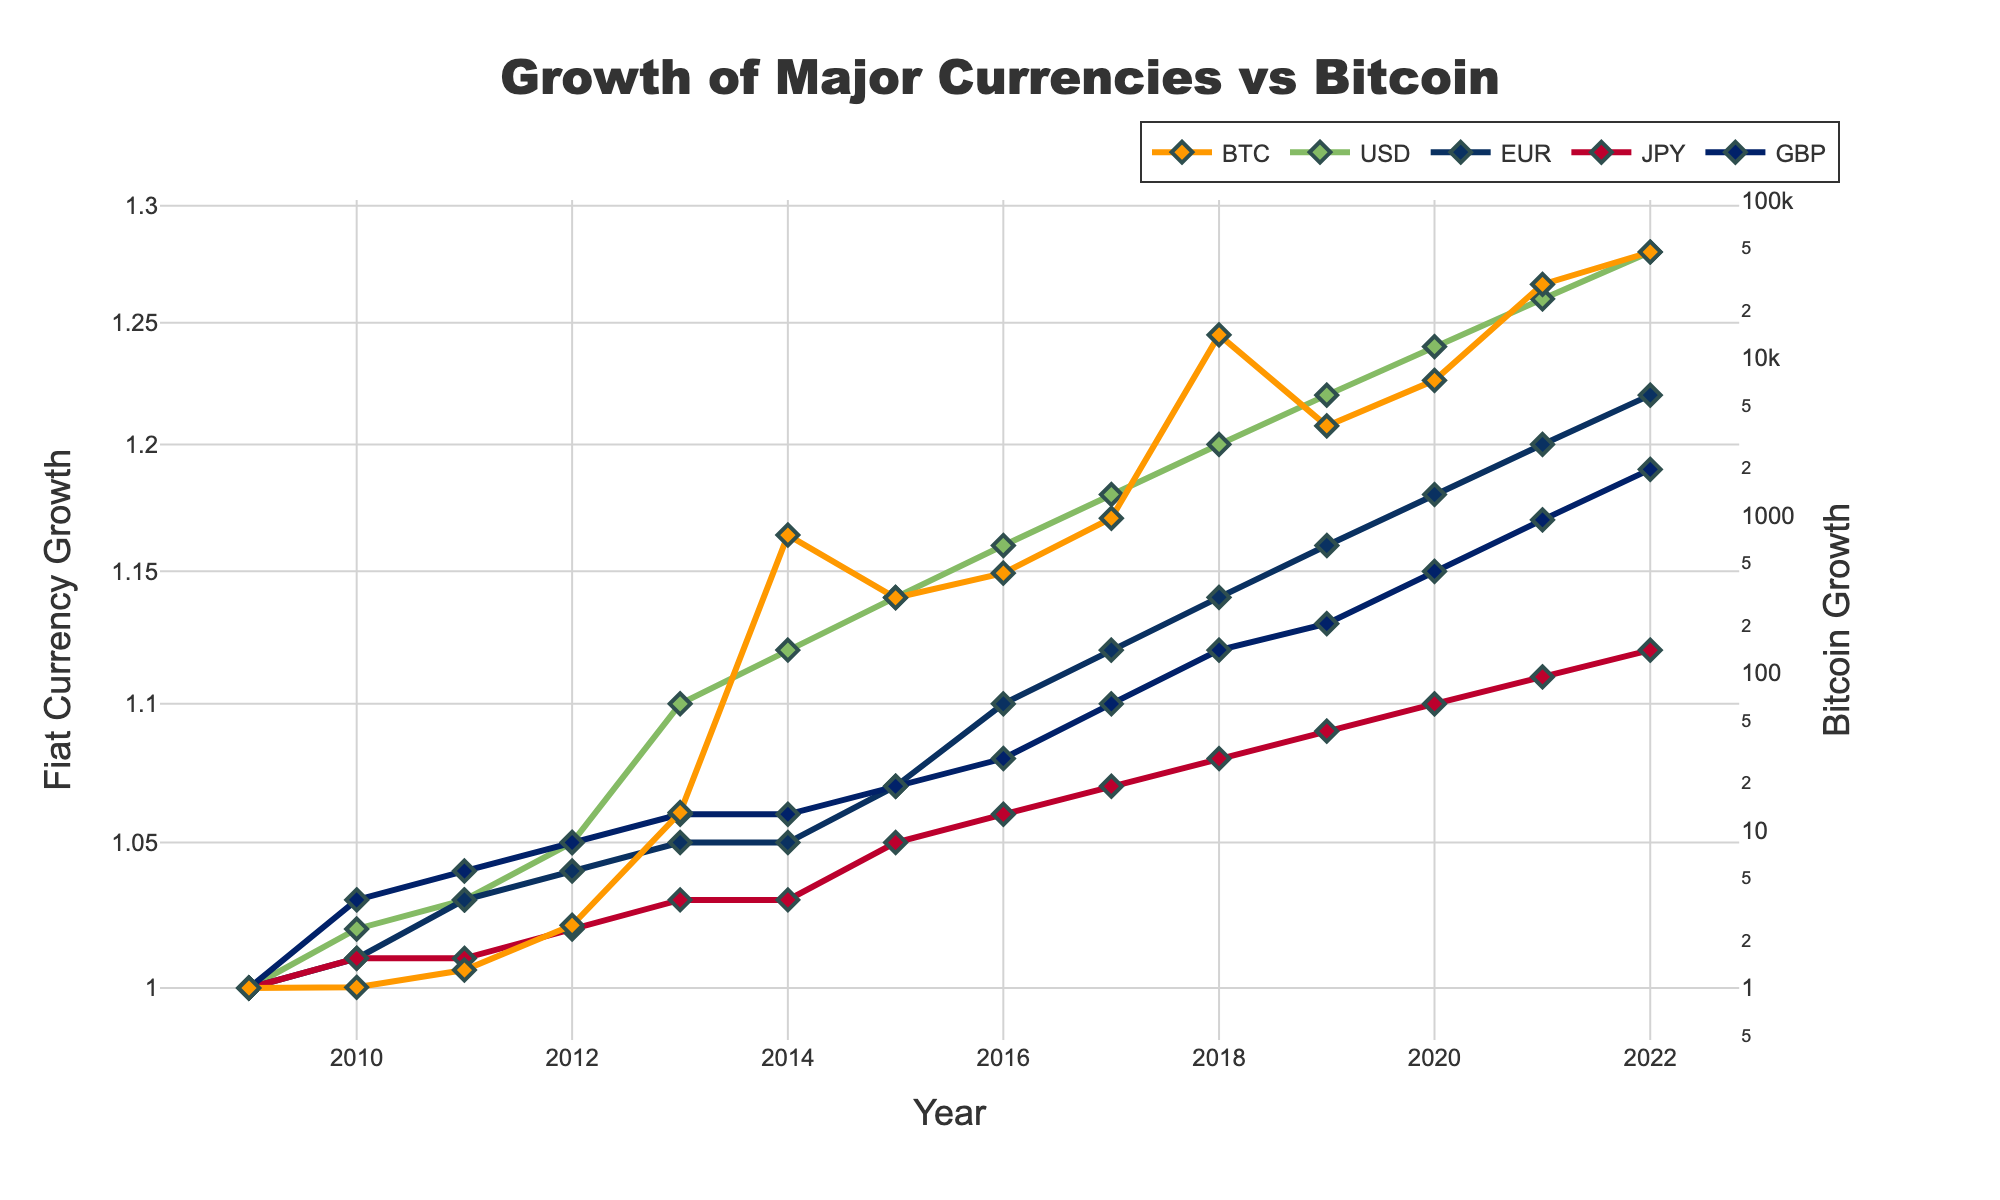Which currency shows the highest growth rate according to the figure? By looking at the figure, we can see that Bitcoin (BTC) has experienced the highest growth rate compared to the other fiat currencies, as represented by its steep line on the log scale.
Answer: Bitcoin What is the title of the figure? The title is typically found at the top of the figure. According to the code provided, the title of the figure is "Growth of Major Currencies vs Bitcoin".
Answer: Growth of Major Currencies vs Bitcoin Between which years did Bitcoin (BTC) experience the most significant increase in its growth rate? By examining the point where the Bitcoin line becomes most vertical, we can observe that between 2013 and 2014, Bitcoin experienced the most significant increase in its growth rate.
Answer: 2013-2014 How does the growth rate of the US Dollar (USD) compare to that of the Euro (EUR) from 2009 to 2022? By comparing the lines representing USD and EUR in the figure, we can see that the growth rates of both currencies are very close, with USD slightly outperforming EUR over time.
Answer: USD slightly higher By how much did Bitcoin's growth value increase from 2021 to 2022? From the figure, the value of Bitcoin in 2021 is 29,300 and in 2022 it is 47,000. The increase is calculated as 47,000 - 29,300 = 17,700.
Answer: 17,700 Which fiat currency had the smallest change in growth rate over the years? By observing the fiat currency lines, we can see that the Japanese Yen (JPY) line is the flattest, indicating the smallest change in growth rate over the years.
Answer: Japanese Yen What axis title is used for the primary y-axis representing fiat currency growth? According to the code, the title text for the primary y-axis is "Fiat Currency Growth".
Answer: Fiat Currency Growth What is the general trend of Bitcoin's growth compared to the fiat currencies from inception till 2022? By analyzing the log scale line plot, it is evident that Bitcoin's growth follows an exponential trend, significantly outperforming the fiat currencies which have grown very modestly.
Answer: Exponential growth 